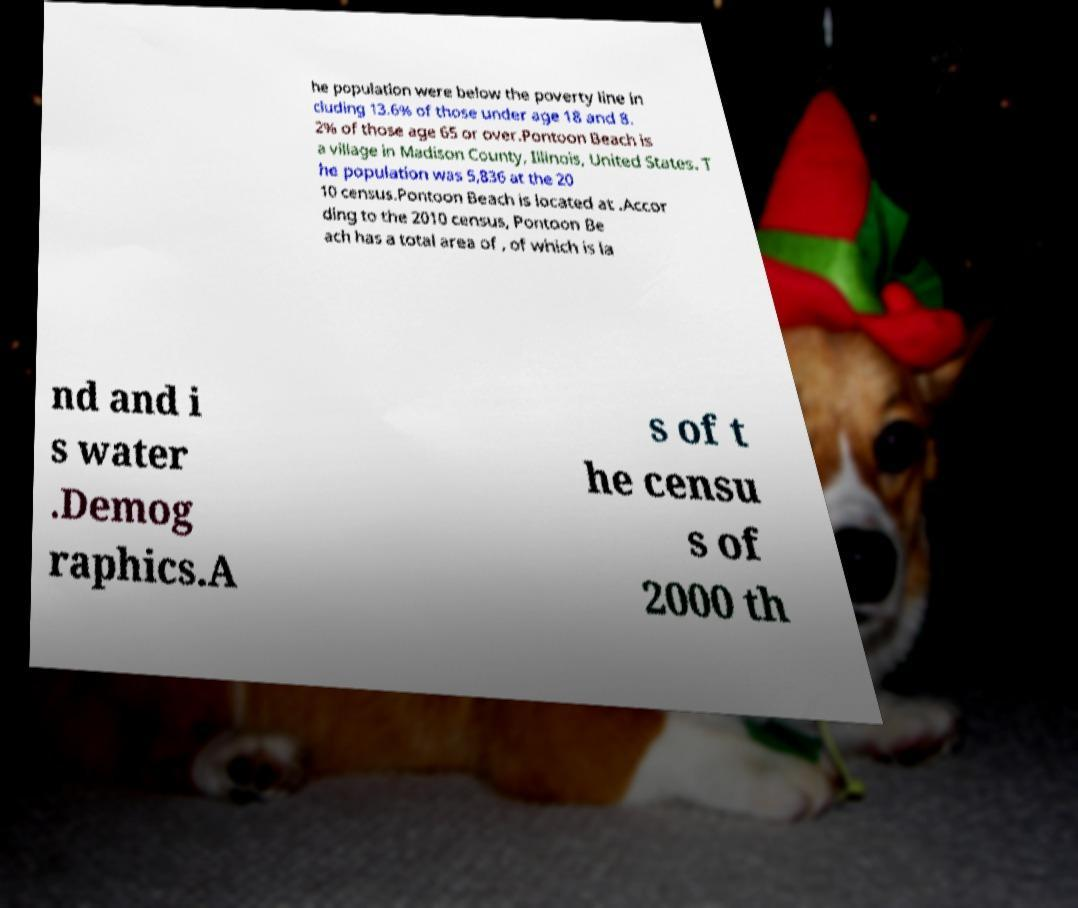Can you read and provide the text displayed in the image?This photo seems to have some interesting text. Can you extract and type it out for me? he population were below the poverty line in cluding 13.6% of those under age 18 and 8. 2% of those age 65 or over.Pontoon Beach is a village in Madison County, Illinois, United States. T he population was 5,836 at the 20 10 census.Pontoon Beach is located at .Accor ding to the 2010 census, Pontoon Be ach has a total area of , of which is la nd and i s water .Demog raphics.A s of t he censu s of 2000 th 